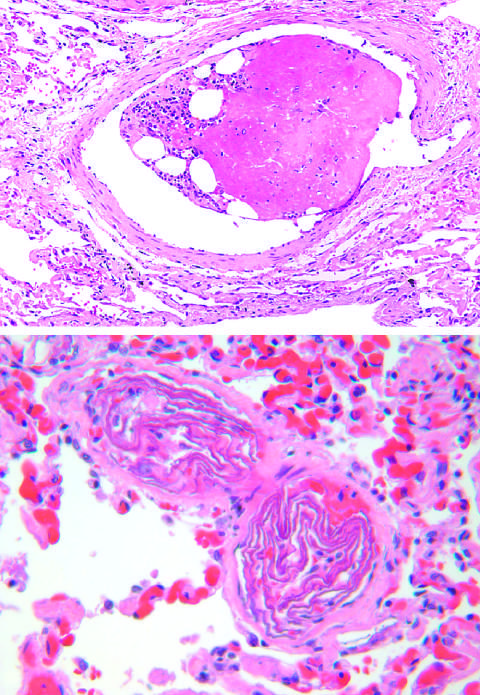re two small pulmonary arterioles packed with laminated swirls of fetal squamous cells?
Answer the question using a single word or phrase. Yes 